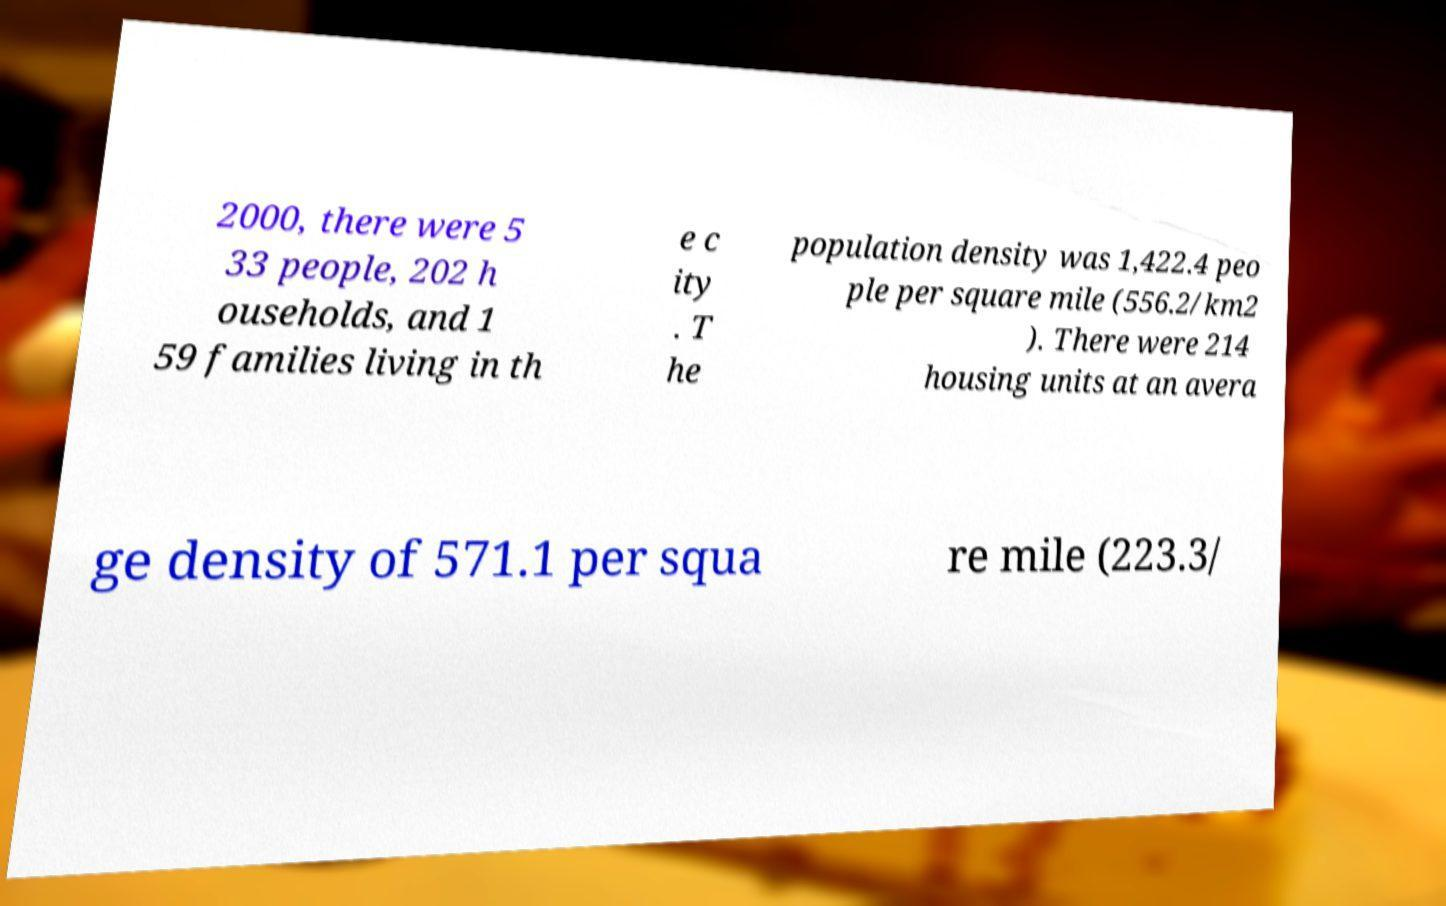What messages or text are displayed in this image? I need them in a readable, typed format. 2000, there were 5 33 people, 202 h ouseholds, and 1 59 families living in th e c ity . T he population density was 1,422.4 peo ple per square mile (556.2/km2 ). There were 214 housing units at an avera ge density of 571.1 per squa re mile (223.3/ 